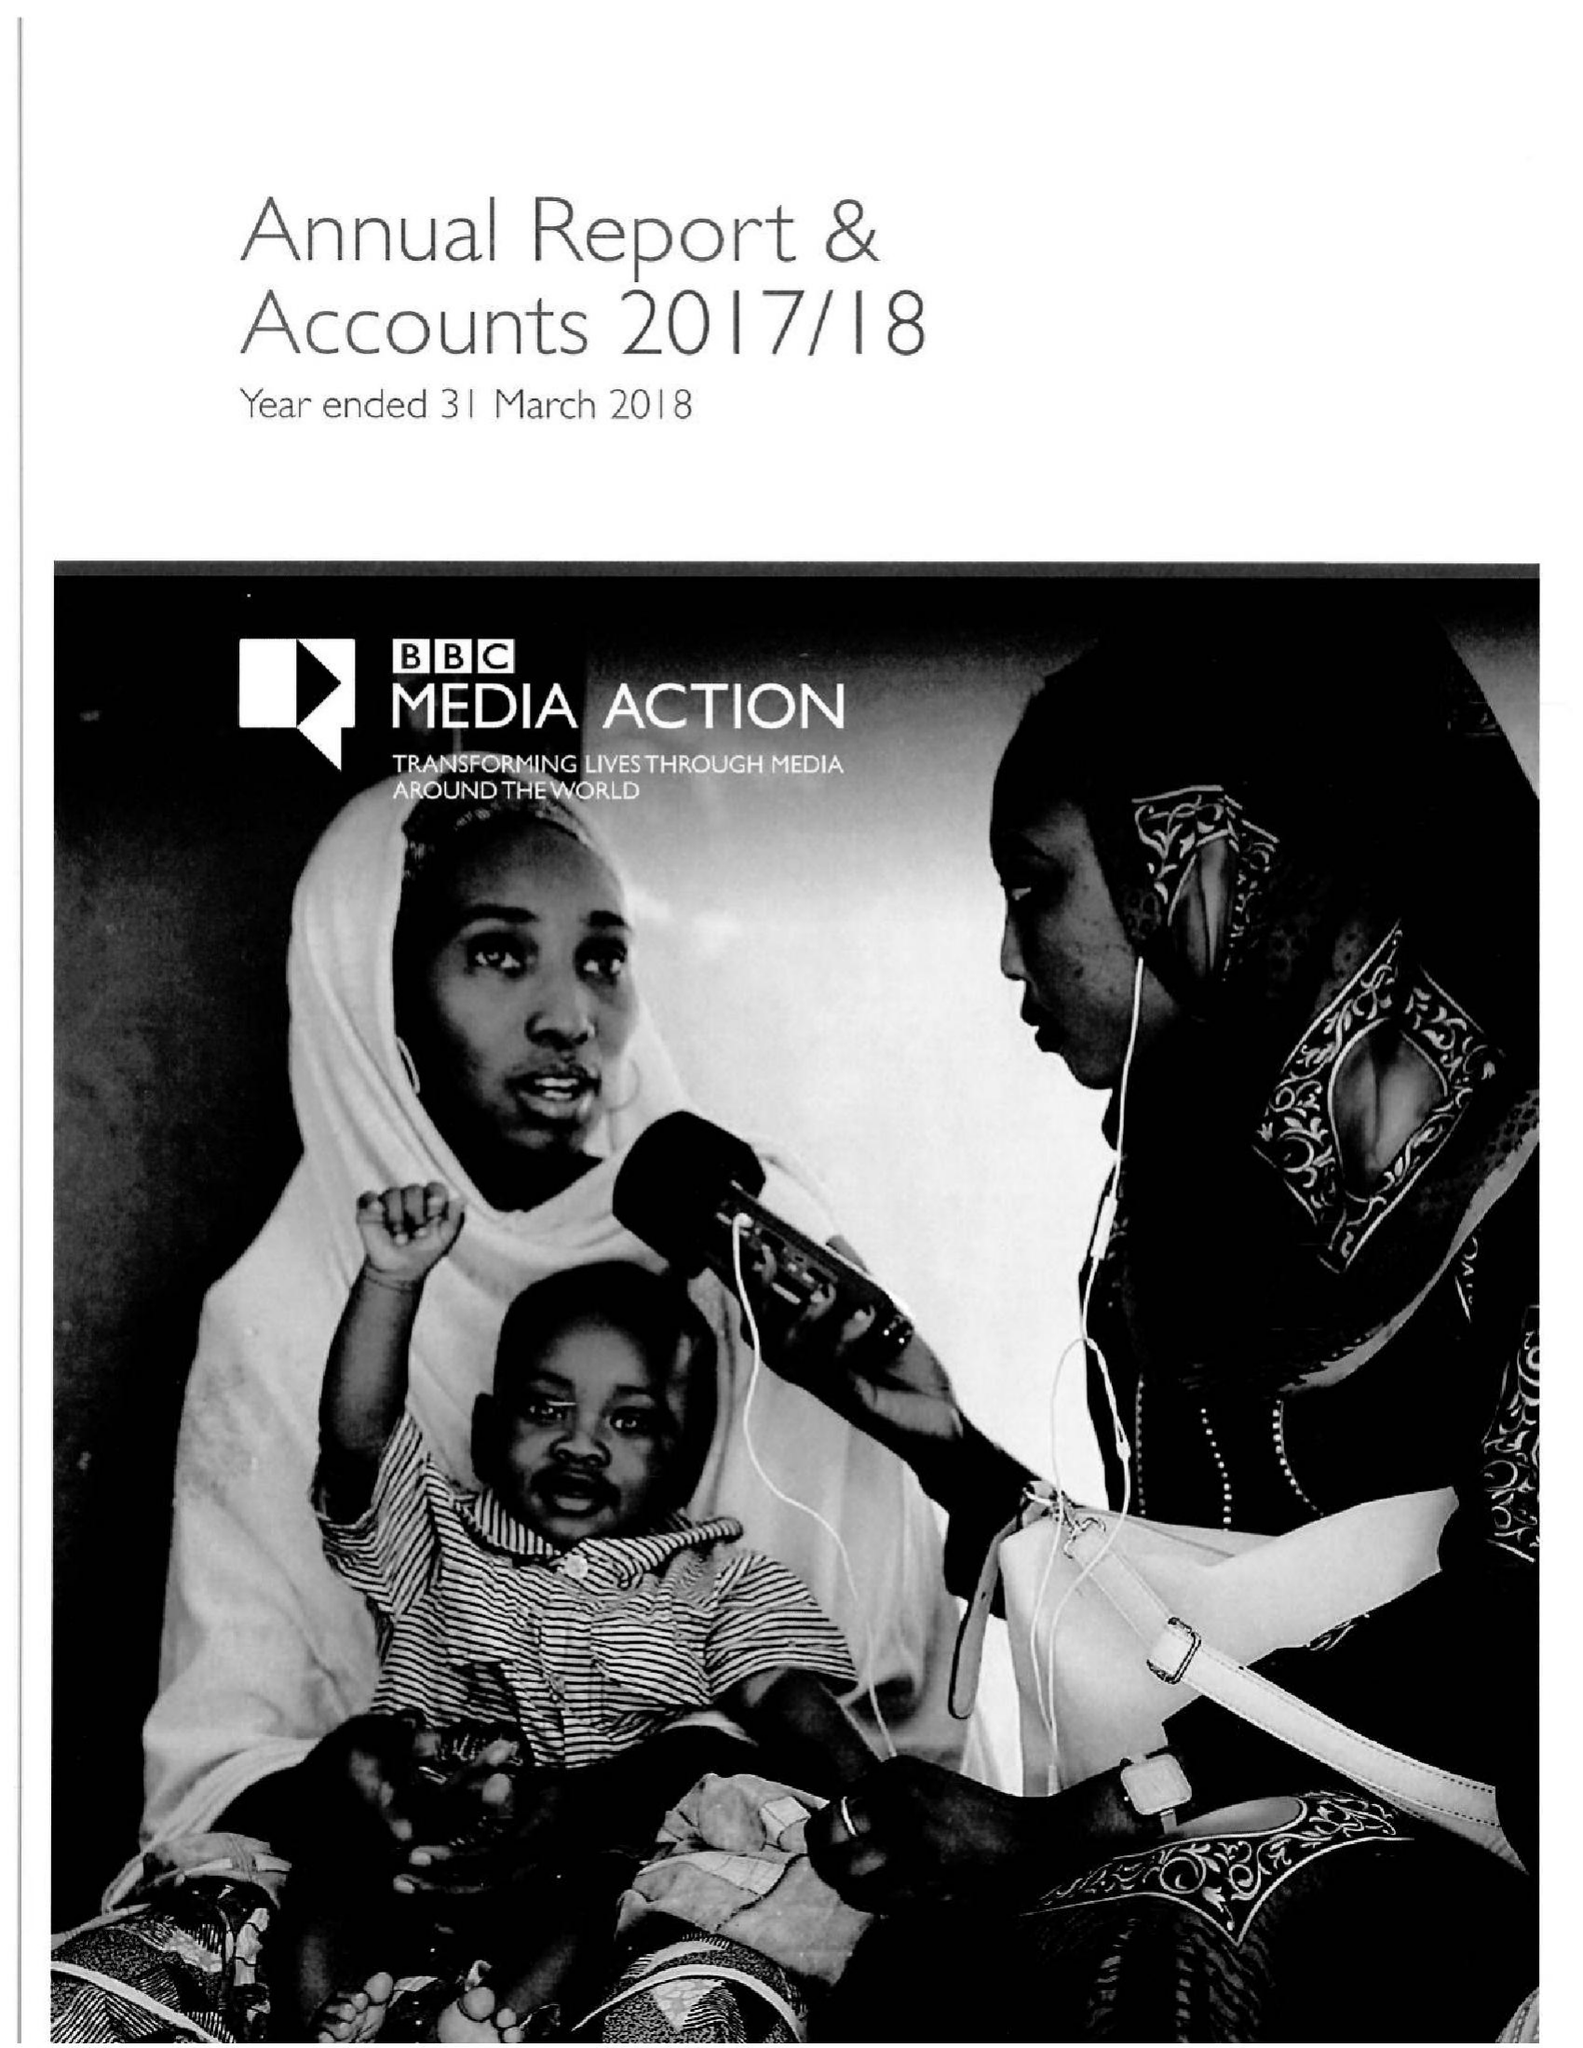What is the value for the address__street_line?
Answer the question using a single word or phrase. PORTLAND PLACE 